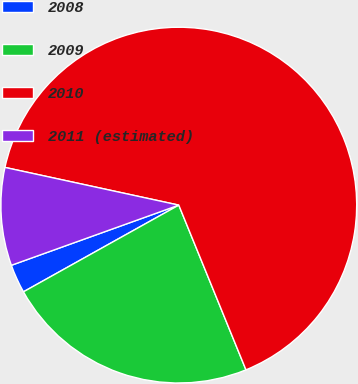Convert chart. <chart><loc_0><loc_0><loc_500><loc_500><pie_chart><fcel>2008<fcel>2009<fcel>2010<fcel>2011 (estimated)<nl><fcel>2.61%<fcel>23.06%<fcel>65.43%<fcel>8.89%<nl></chart> 